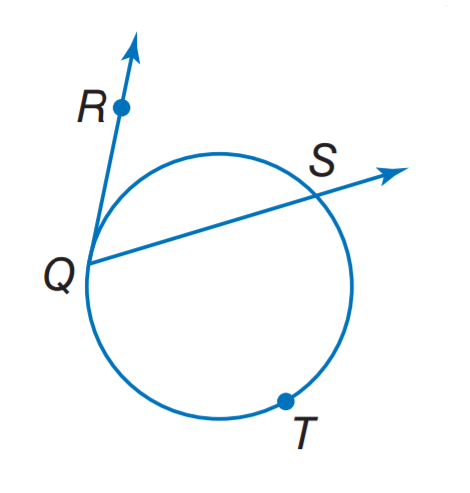Answer the mathemtical geometry problem and directly provide the correct option letter.
Question: Find m \widehat R Q S if m \widehat Q T S = 238.
Choices: A: 29 B: 61 C: 83 D: 119 B 